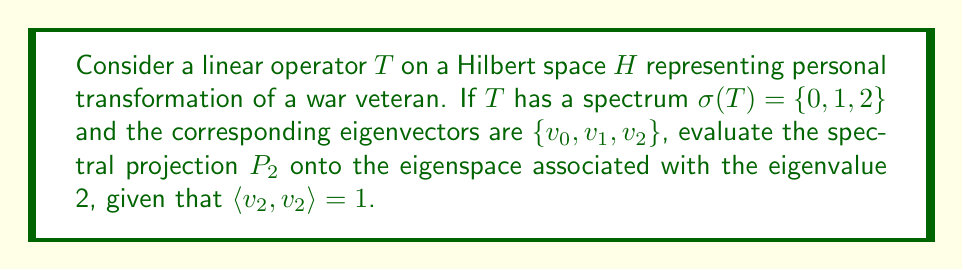Solve this math problem. 1) The spectral projection $P_2$ onto the eigenspace associated with eigenvalue 2 is given by:

   $$P_2 = \frac{v_2 \otimes v_2^*}{\langle v_2, v_2 \rangle}$$

2) We are given that $\langle v_2, v_2 \rangle = 1$, so this simplifies to:

   $$P_2 = v_2 \otimes v_2^*$$

3) In terms of how $P_2$ acts on a vector $x \in H$:

   $$P_2x = (v_2 \otimes v_2^*)x = \langle x, v_2 \rangle v_2$$

4) This projection represents the component of personal transformation associated with the most significant change (eigenvalue 2).

5) The projection $P_2$ is idempotent $(P_2^2 = P_2)$ and self-adjoint $(P_2^* = P_2)$.

6) In the context of personal transformation, this projection isolates the aspect of change associated with the most profound shift in the veteran's perspective or behavior.
Answer: $P_2 = v_2 \otimes v_2^*$ 